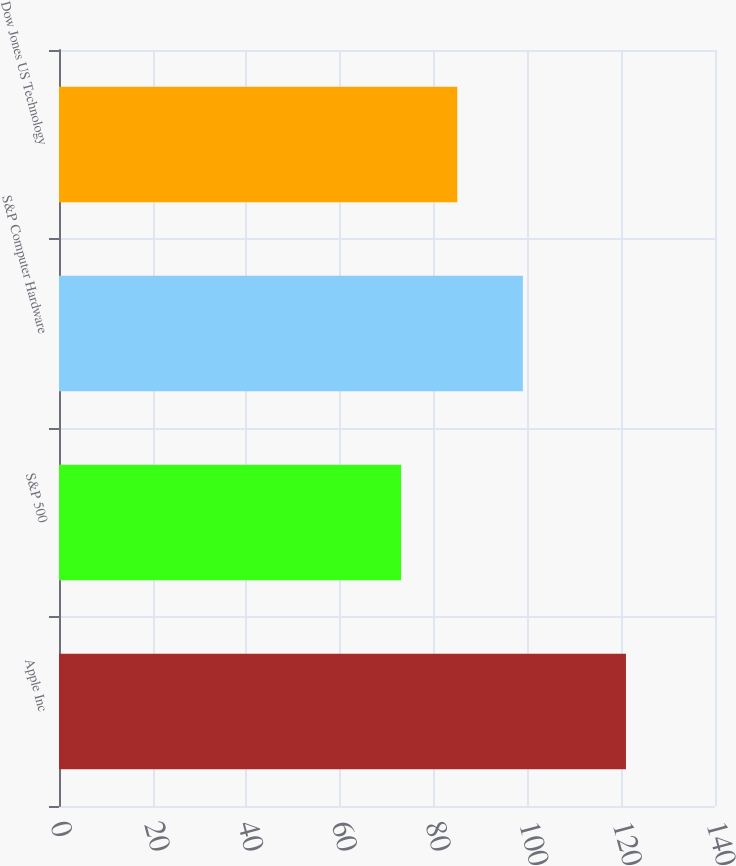Convert chart. <chart><loc_0><loc_0><loc_500><loc_500><bar_chart><fcel>Apple Inc<fcel>S&P 500<fcel>S&P Computer Hardware<fcel>Dow Jones US Technology<nl><fcel>121<fcel>73<fcel>99<fcel>85<nl></chart> 